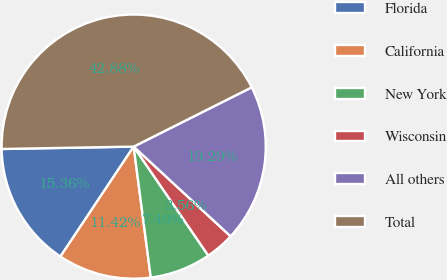Convert chart to OTSL. <chart><loc_0><loc_0><loc_500><loc_500><pie_chart><fcel>Florida<fcel>California<fcel>New York<fcel>Wisconsin<fcel>All others<fcel>Total<nl><fcel>15.36%<fcel>11.42%<fcel>7.49%<fcel>3.56%<fcel>19.29%<fcel>42.88%<nl></chart> 